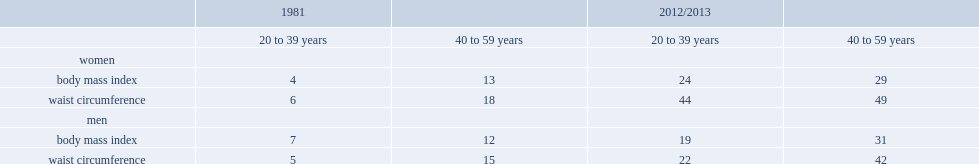What were the obesity rates among women aged 20 to 39 in 1981 and2012/2013 respectively? 4.0 24.0. 